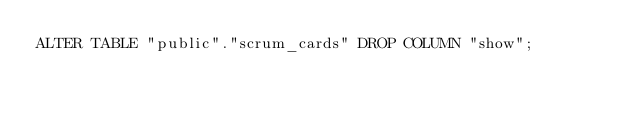Convert code to text. <code><loc_0><loc_0><loc_500><loc_500><_SQL_>ALTER TABLE "public"."scrum_cards" DROP COLUMN "show";
</code> 